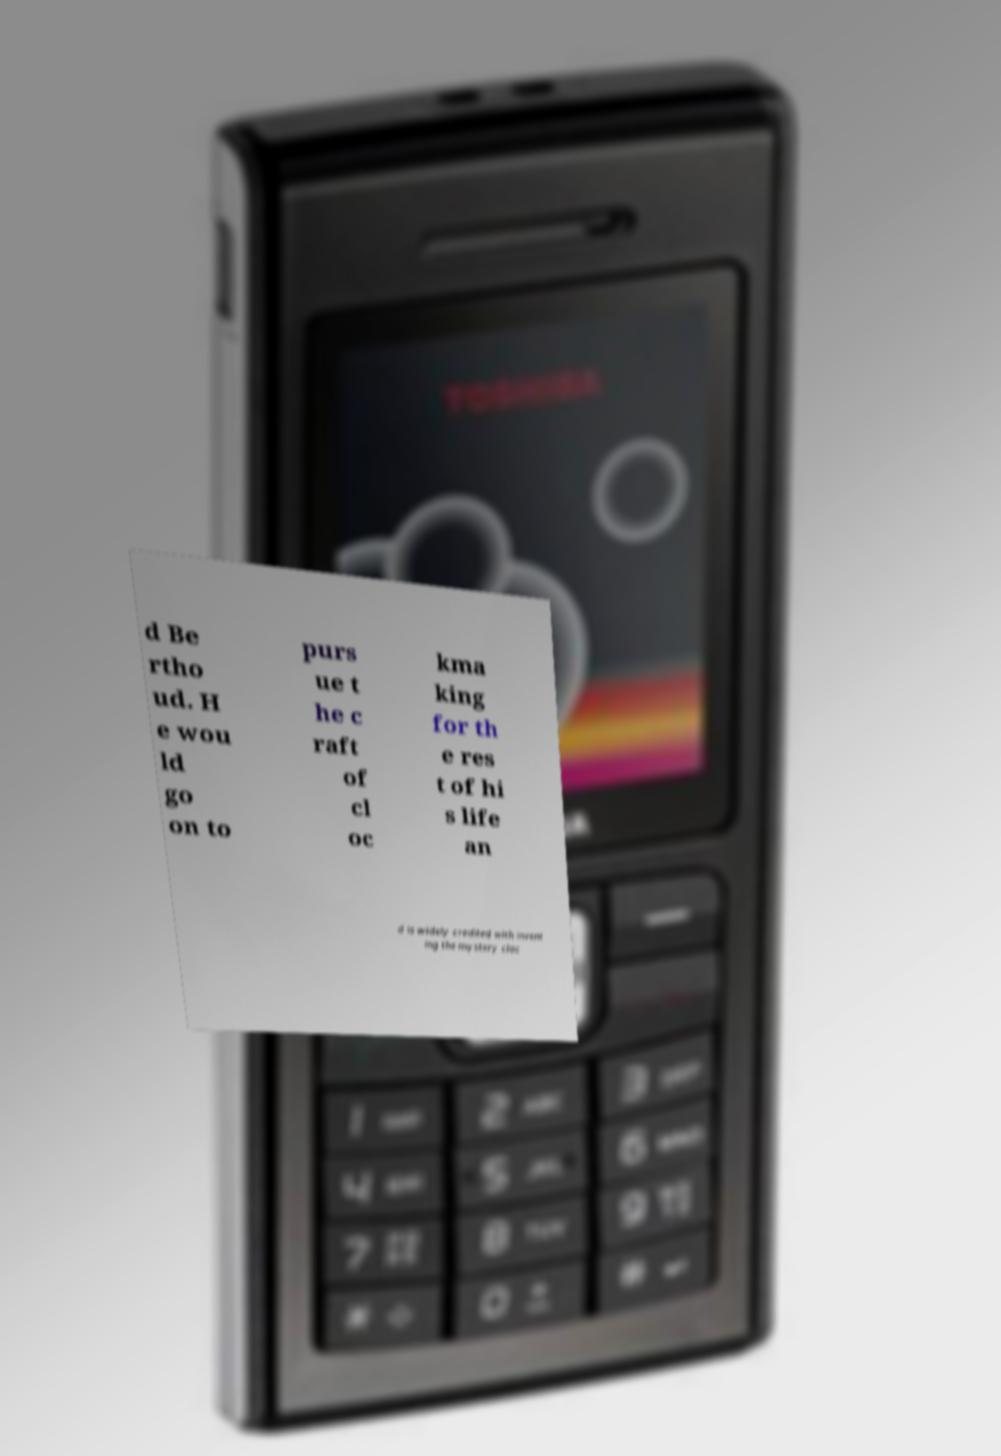For documentation purposes, I need the text within this image transcribed. Could you provide that? d Be rtho ud. H e wou ld go on to purs ue t he c raft of cl oc kma king for th e res t of hi s life an d is widely credited with invent ing the mystery cloc 